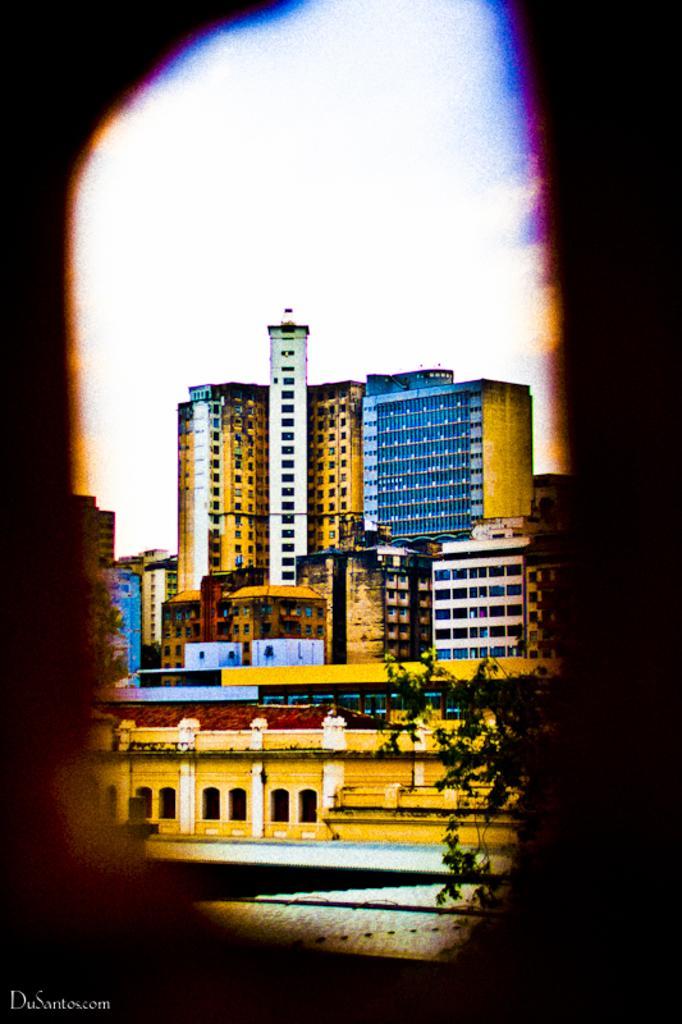Can you describe this image briefly? In this image we can see a few buildings, there are some windows and trees, in the background we can see the sky. 